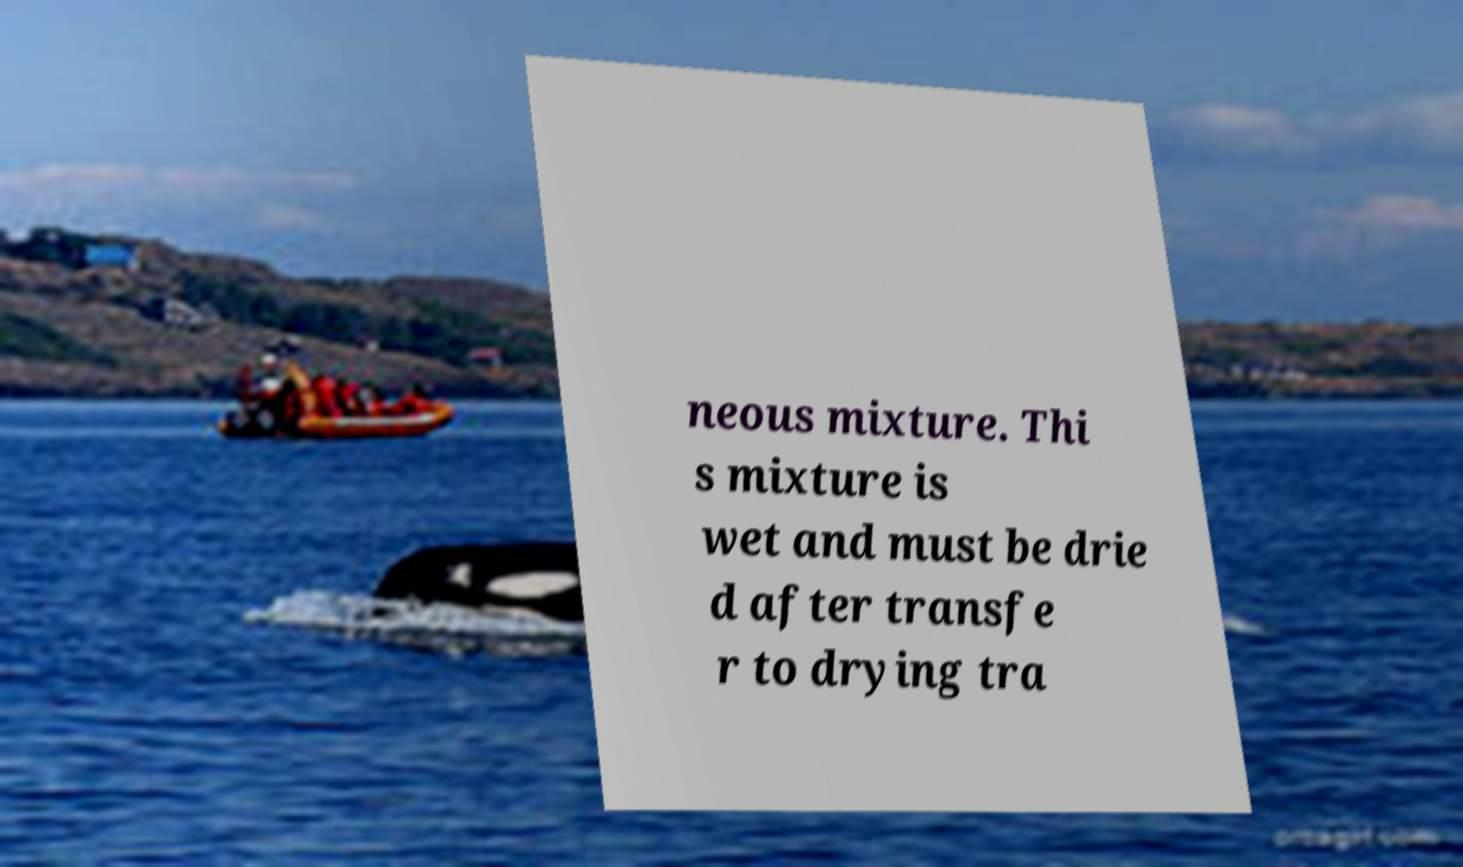Please identify and transcribe the text found in this image. neous mixture. Thi s mixture is wet and must be drie d after transfe r to drying tra 